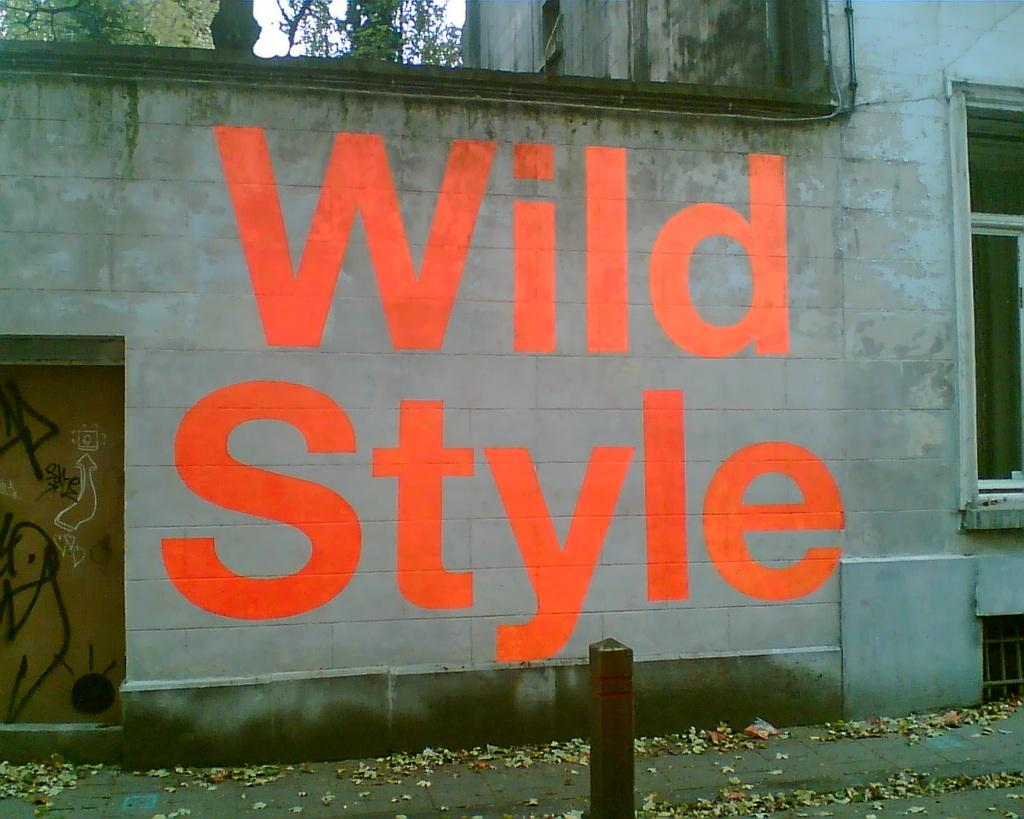What can be seen on the wall of the building in the image? There is writing on the wall of a building in the image. What architectural feature is located on the left side of the building? There is a door on the left side of the building in the image. What feature is on the right side of the building? There is a window on the right side of the building in the image. What type of vegetation is visible behind the building? There are trees visible at the back of the building in the image. What type of bait is being used to catch fish in the image? There is no fishing or bait present in the image; it features a building with writing on the wall, a door, a window, and trees in the background. How many seats are visible in the image? There are no seats visible in the image; it features a building with writing on the wall, a door, a window, and trees in the background. 